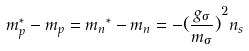Convert formula to latex. <formula><loc_0><loc_0><loc_500><loc_500>m _ { p } ^ { * } - m _ { p } = { m _ { n } } ^ { * } - m _ { n } = - { ( \frac { g _ { \sigma } } { m _ { \sigma } } ) } ^ { 2 } { n _ { s } }</formula> 